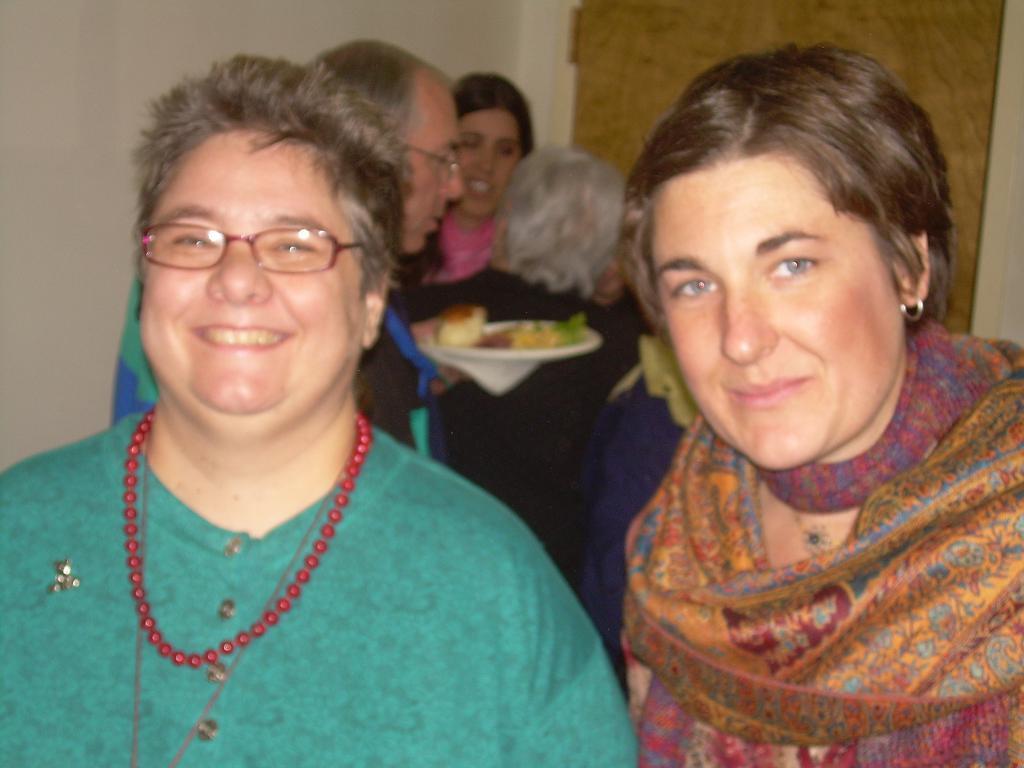Can you describe this image briefly? There are people, these two people smiling and he is holding plate with food. In the background we can see wall and door. 